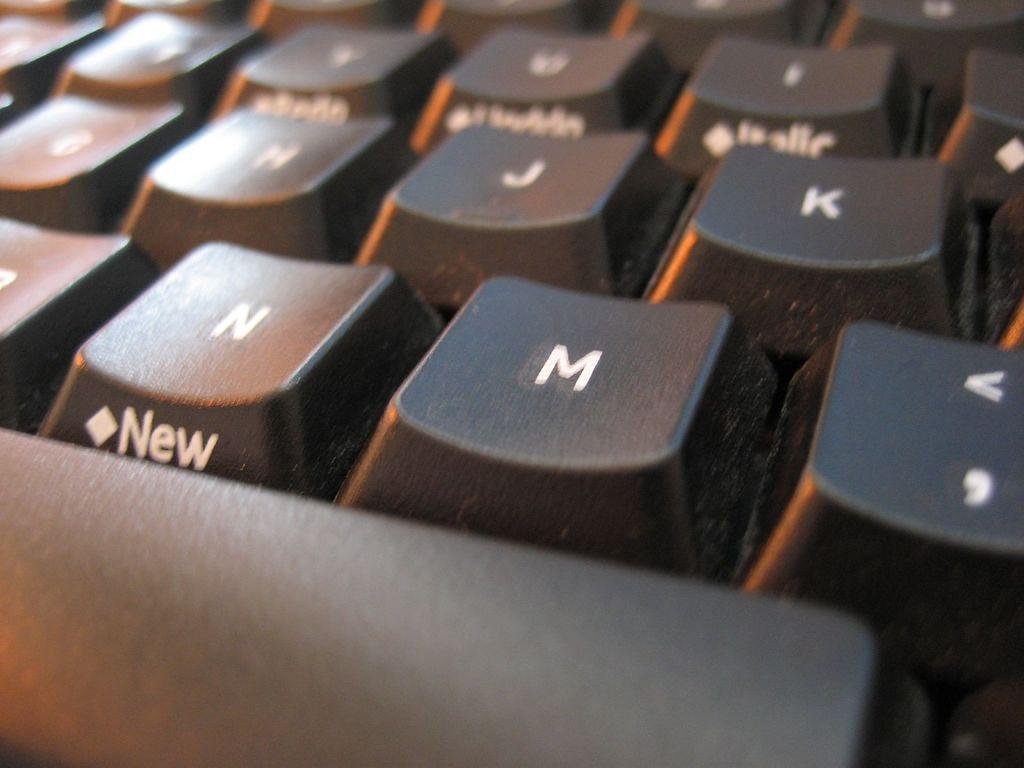<image>
Summarize the visual content of the image. A close up of a keyboard with the word New on the N button. 